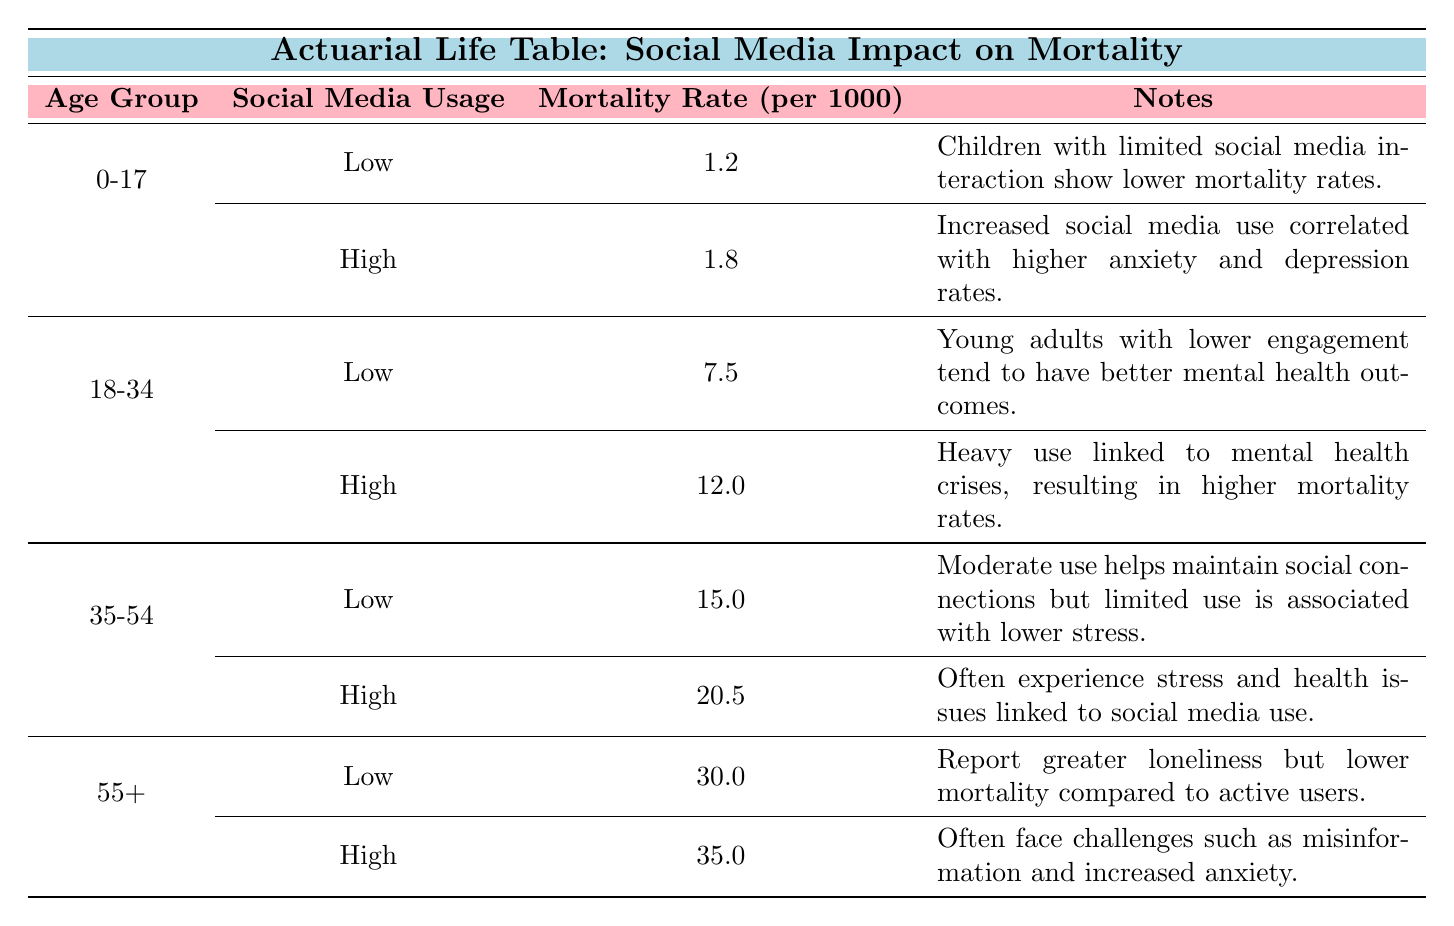What is the mortality rate for the age group 18-34 with high social media usage? According to the table, under the 18-34 age group with high social media usage, the mortality rate is listed as 12.0 per 1000.
Answer: 12.0 What is the mortality rate per 1000 for children aged 0-17 who use social media at a low level? The table states that for the age group 0-17 with low social media usage, the mortality rate is 1.2 per 1000.
Answer: 1.2 Is the mortality rate for adults over 55 with high social media usage higher than those with low usage? Yes, the table shows that the mortality rate for the 55+ age group with high social media usage is 35.0, while those with low usage have a rate of 30.0, indicating that high usage results in a higher mortality rate.
Answer: Yes What is the difference in mortality rates between the age group 35-54 with high and low social media usage? For the age group 35-54, the mortality rate with high social media usage is 20.5, while with low usage it is 15.0. The difference is 20.5 - 15.0 = 5.5 per 1000.
Answer: 5.5 What is the average mortality rate across all age groups for low social media usage? The table provides the following rates for low social media usage: 1.2 (0-17) + 7.5 (18-34) + 15.0 (35-54) + 30.0 (55+) = 53.7. There are 4 age groups, so the average is 53.7 / 4 = 13.425 per 1000.
Answer: 13.425 What note is associated with high social media usage in the age group 18-34? The note indicates that heavy social media use is linked to mental health crises, which have resulted in higher mortality rates in this age group.
Answer: Heavy use linked to mental health crises Do individuals aged 0-17 with high social media usage show a lower mortality rate than those aged 18-34 with low usage? No, the table indicates that the mortality rate for 0-17 with high usage is 1.8, whereas for 18-34 with low usage it is 7.5, showing that the latter group has a higher rate.
Answer: No What is the total mortality rate per 1000 for adults aged 35-54, combining both social media usage levels? For the age group 35-54, the rates are 15.0 (low) and 20.5 (high), which totals to 15.0 + 20.5 = 35.5 per 1000.
Answer: 35.5 What can be inferred about the relationship between social media usage and mortality rates for older adults? The table suggests that higher social media usage among older adults (55+) is correlated with increased mortality rates, as indicated by the higher rate of 35.0 compared to 30.0 for low usage.
Answer: Higher usage relates to higher mortality 